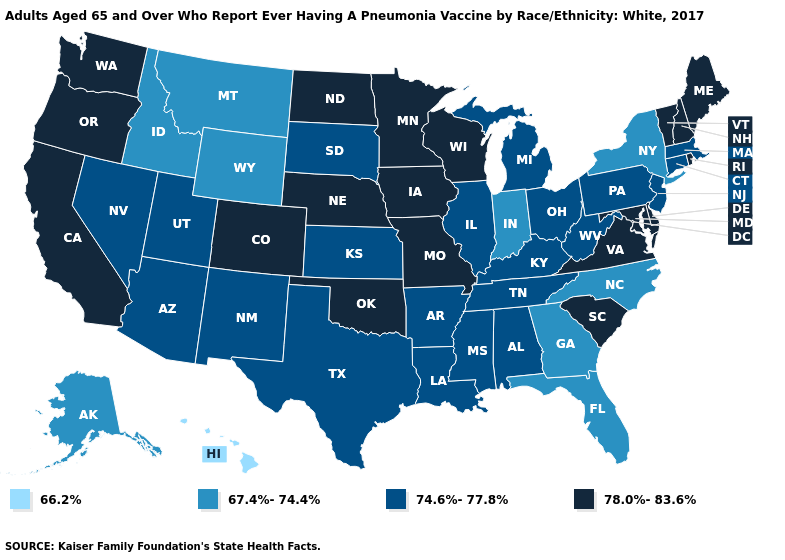Does New Jersey have the lowest value in the USA?
Short answer required. No. Which states have the lowest value in the MidWest?
Be succinct. Indiana. Does the map have missing data?
Answer briefly. No. Name the states that have a value in the range 66.2%?
Quick response, please. Hawaii. Which states have the highest value in the USA?
Concise answer only. California, Colorado, Delaware, Iowa, Maine, Maryland, Minnesota, Missouri, Nebraska, New Hampshire, North Dakota, Oklahoma, Oregon, Rhode Island, South Carolina, Vermont, Virginia, Washington, Wisconsin. Which states have the lowest value in the USA?
Write a very short answer. Hawaii. What is the value of Oregon?
Write a very short answer. 78.0%-83.6%. Which states hav the highest value in the South?
Be succinct. Delaware, Maryland, Oklahoma, South Carolina, Virginia. What is the lowest value in the Northeast?
Quick response, please. 67.4%-74.4%. What is the value of Rhode Island?
Keep it brief. 78.0%-83.6%. Does Colorado have the highest value in the West?
Keep it brief. Yes. Name the states that have a value in the range 66.2%?
Be succinct. Hawaii. What is the highest value in the USA?
Write a very short answer. 78.0%-83.6%. What is the value of Rhode Island?
Write a very short answer. 78.0%-83.6%. Name the states that have a value in the range 66.2%?
Quick response, please. Hawaii. 